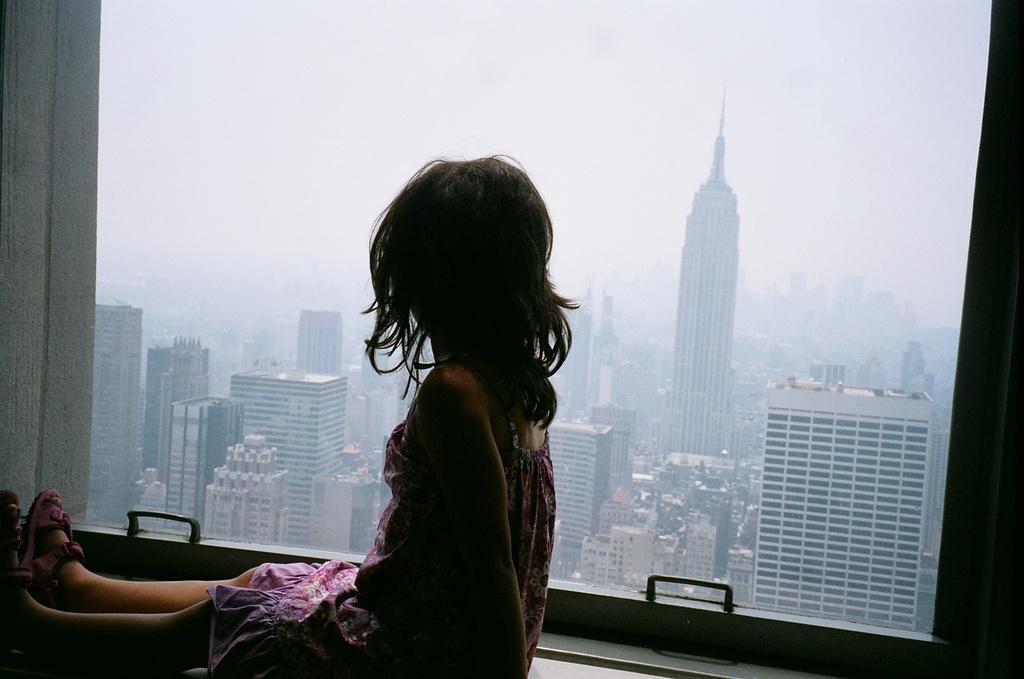How would you summarize this image in a sentence or two? In the picture we can see a girl child sitting near the window and from the glass window we can see buildings, tower buildings and sky. 